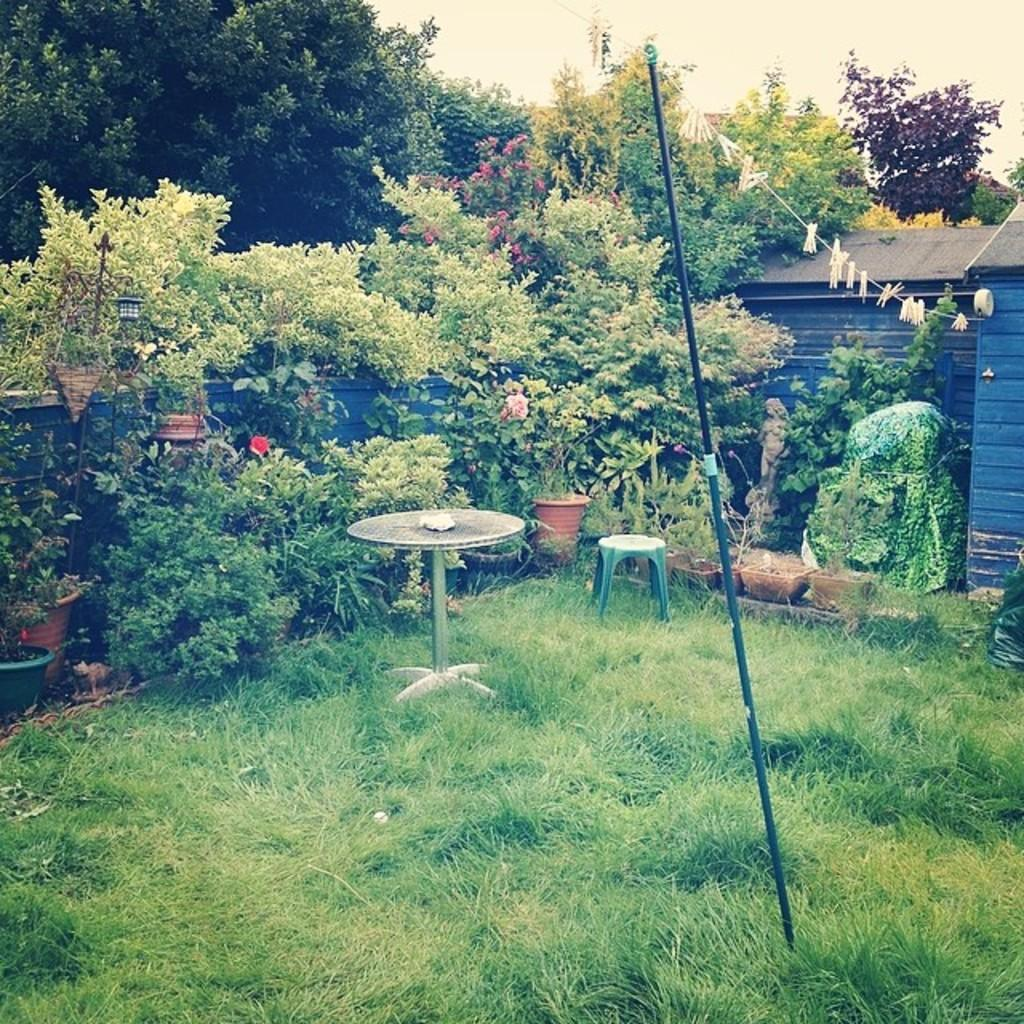What type of surface is on the ground in the image? There is grass on the ground in the image. What type of furniture is present in the image? There is a table and a stool in the image. What type of vegetation is present in the image? There are plants and trees in the image. What can be seen in the background of the image? The sky is visible in the background of the image. How many frogs are sitting on the table in the image? There are no frogs present in the image. What type of match is being played on the grass in the image? There is no match or any sports activity depicted in the image. 